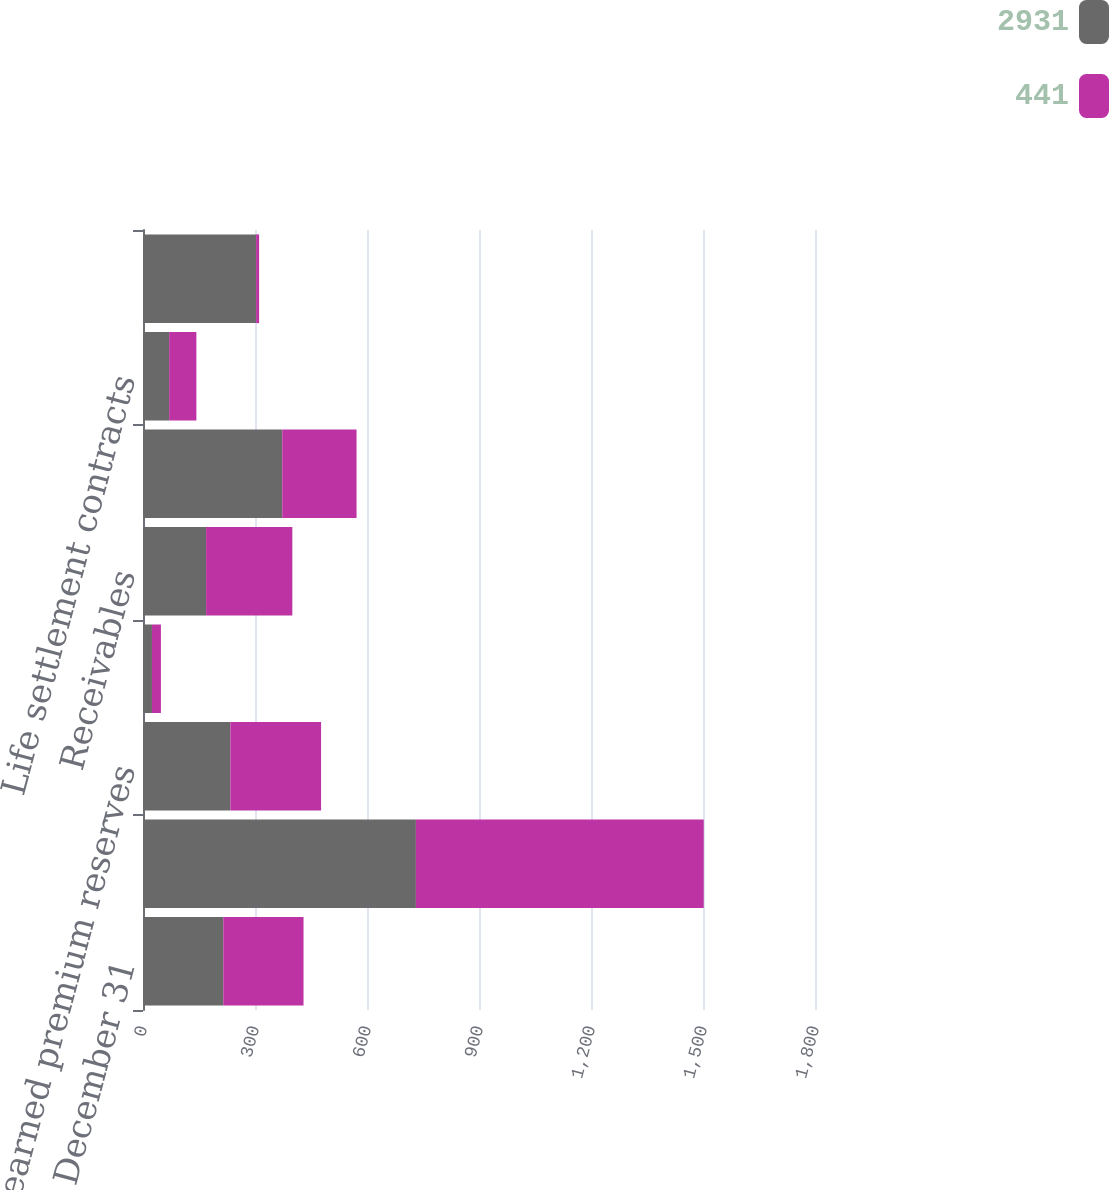Convert chart to OTSL. <chart><loc_0><loc_0><loc_500><loc_500><stacked_bar_chart><ecel><fcel>December 31<fcel>Property and casualty claim<fcel>Unearned premium reserves<fcel>Other insurance reserves<fcel>Receivables<fcel>Employee benefits<fcel>Life settlement contracts<fcel>Investment valuation<nl><fcel>2931<fcel>215<fcel>731<fcel>234<fcel>24<fcel>169<fcel>373<fcel>70<fcel>303<nl><fcel>441<fcel>215<fcel>771<fcel>243<fcel>24<fcel>231<fcel>199<fcel>73<fcel>8<nl></chart> 